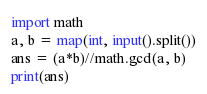Convert code to text. <code><loc_0><loc_0><loc_500><loc_500><_Python_>import math
a, b = map(int, input().split())
ans = (a*b)//math.gcd(a, b)
print(ans)</code> 